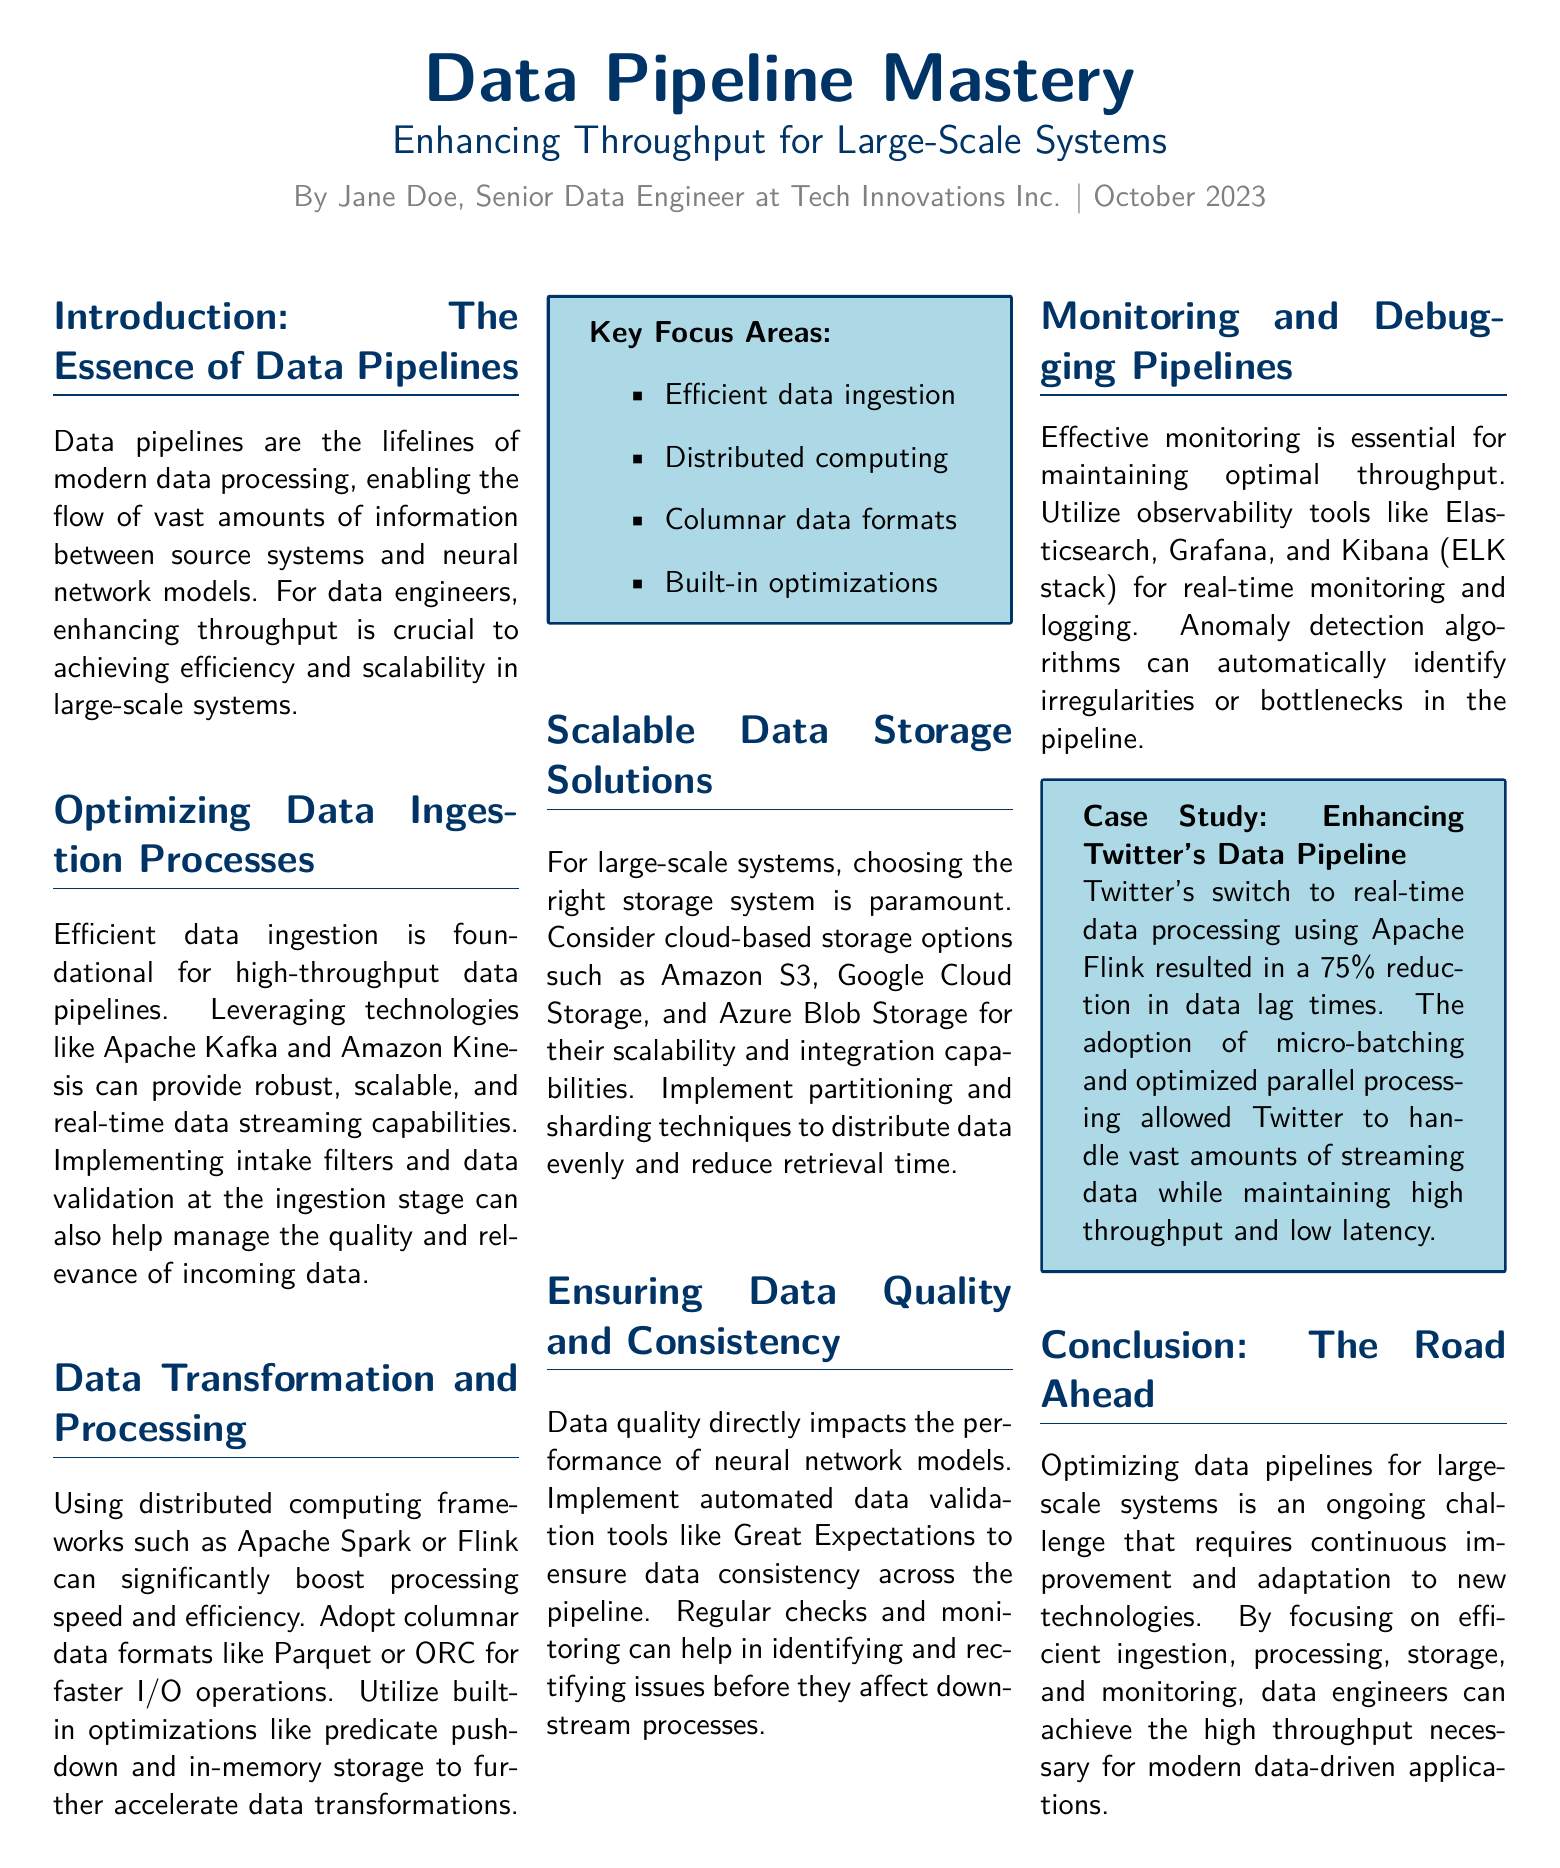What is the title of the document? The title of the document is stated in the heading at the top of the page.
Answer: Data Pipeline Mastery Who is the author of the article? The author's name is included below the title in the byline.
Answer: Jane Doe What month and year was this article published? The month and year of publication are found at the end of the byline.
Answer: October 2023 What technology is mentioned for efficient data ingestion? The document lists technologies that are foundational for data ingestion.
Answer: Apache Kafka What is the percentage reduction in data lag times for Twitter? The document states the specific improvement achieved by Twitter's pipeline optimization.
Answer: 75% Which framework is recommended for distributed computing? The section discusses technologies suitable for boosting processing speed in data pipelines.
Answer: Apache Spark What storage solution is recommended for scalability? This is mentioned under scalable data storage solutions as suitable for large systems.
Answer: Amazon S3 What is a recommended tool for automated data validation? The document mentions a specific tool focused on data quality and consistency.
Answer: Great Expectations What observability tools are suggested for monitoring pipelines? The document provides examples of tools for monitoring and logging.
Answer: ELK stack 